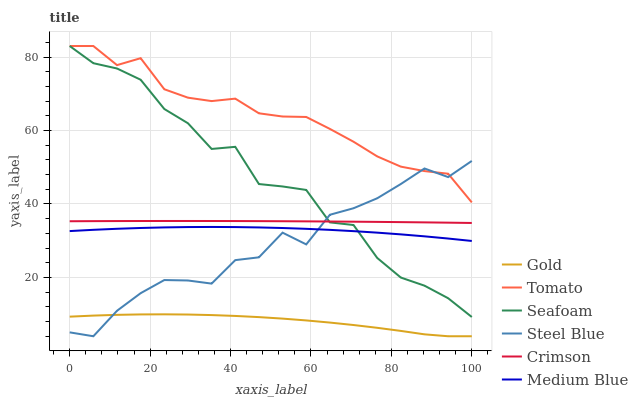Does Gold have the minimum area under the curve?
Answer yes or no. Yes. Does Tomato have the maximum area under the curve?
Answer yes or no. Yes. Does Medium Blue have the minimum area under the curve?
Answer yes or no. No. Does Medium Blue have the maximum area under the curve?
Answer yes or no. No. Is Crimson the smoothest?
Answer yes or no. Yes. Is Seafoam the roughest?
Answer yes or no. Yes. Is Gold the smoothest?
Answer yes or no. No. Is Gold the roughest?
Answer yes or no. No. Does Gold have the lowest value?
Answer yes or no. Yes. Does Medium Blue have the lowest value?
Answer yes or no. No. Does Seafoam have the highest value?
Answer yes or no. Yes. Does Medium Blue have the highest value?
Answer yes or no. No. Is Gold less than Seafoam?
Answer yes or no. Yes. Is Crimson greater than Gold?
Answer yes or no. Yes. Does Steel Blue intersect Gold?
Answer yes or no. Yes. Is Steel Blue less than Gold?
Answer yes or no. No. Is Steel Blue greater than Gold?
Answer yes or no. No. Does Gold intersect Seafoam?
Answer yes or no. No. 